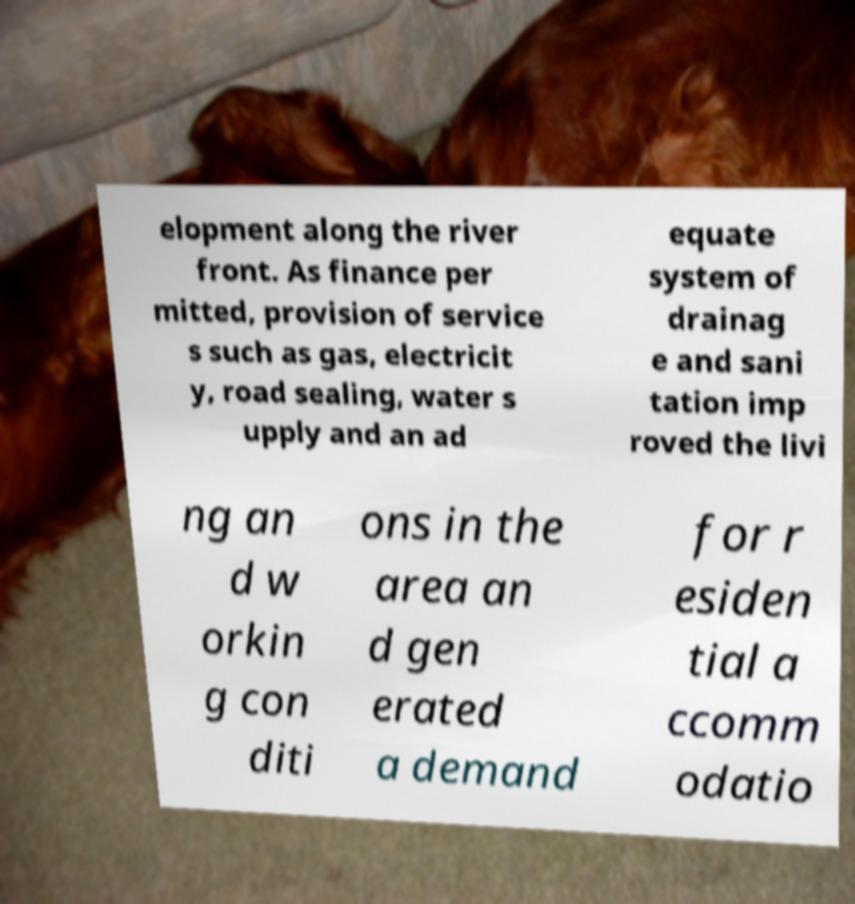Can you read and provide the text displayed in the image?This photo seems to have some interesting text. Can you extract and type it out for me? elopment along the river front. As finance per mitted, provision of service s such as gas, electricit y, road sealing, water s upply and an ad equate system of drainag e and sani tation imp roved the livi ng an d w orkin g con diti ons in the area an d gen erated a demand for r esiden tial a ccomm odatio 